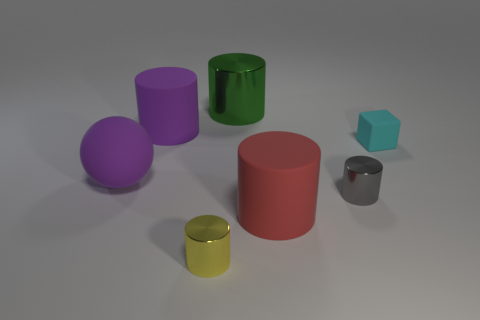Subtract all gray shiny cylinders. How many cylinders are left? 4 Add 3 large brown matte things. How many objects exist? 10 Subtract all green cylinders. How many cylinders are left? 4 Subtract all spheres. How many objects are left? 6 Add 5 gray cylinders. How many gray cylinders exist? 6 Subtract 0 yellow cubes. How many objects are left? 7 Subtract 1 spheres. How many spheres are left? 0 Subtract all blue spheres. Subtract all cyan cubes. How many spheres are left? 1 Subtract all big spheres. Subtract all spheres. How many objects are left? 5 Add 6 green metallic cylinders. How many green metallic cylinders are left? 7 